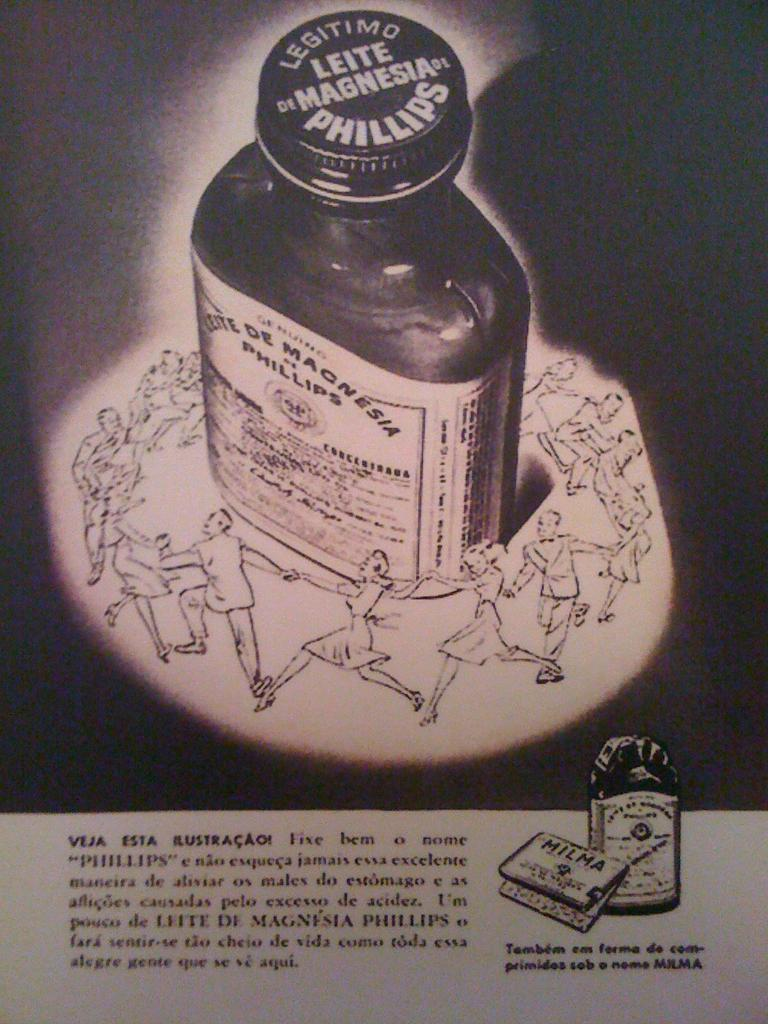<image>
Provide a brief description of the given image. Legitimo Leite of Magnesia by Philips in squarish dark bottle 